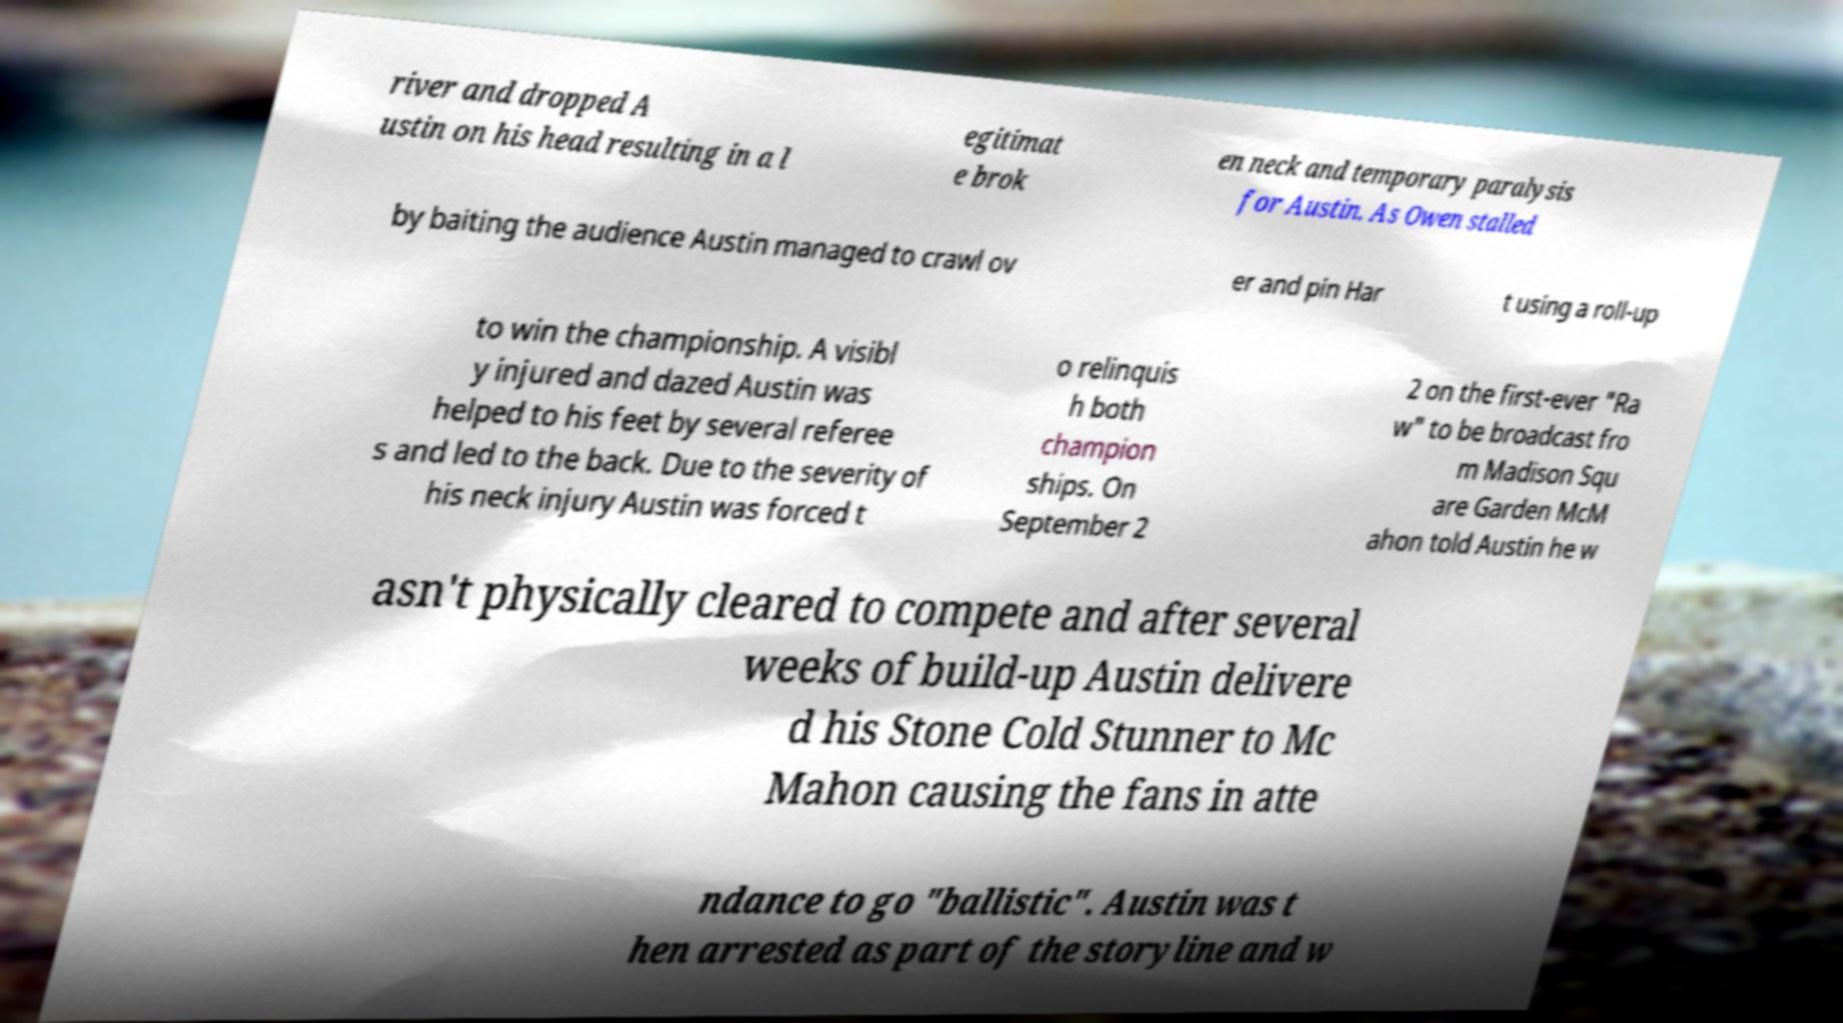I need the written content from this picture converted into text. Can you do that? river and dropped A ustin on his head resulting in a l egitimat e brok en neck and temporary paralysis for Austin. As Owen stalled by baiting the audience Austin managed to crawl ov er and pin Har t using a roll-up to win the championship. A visibl y injured and dazed Austin was helped to his feet by several referee s and led to the back. Due to the severity of his neck injury Austin was forced t o relinquis h both champion ships. On September 2 2 on the first-ever "Ra w" to be broadcast fro m Madison Squ are Garden McM ahon told Austin he w asn't physically cleared to compete and after several weeks of build-up Austin delivere d his Stone Cold Stunner to Mc Mahon causing the fans in atte ndance to go "ballistic". Austin was t hen arrested as part of the storyline and w 